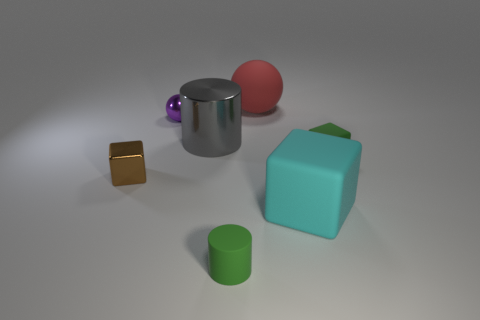What number of green rubber blocks are in front of the small green rubber thing that is behind the green object on the left side of the red matte thing?
Your answer should be compact. 0. There is a green object that is to the right of the cyan rubber block; how big is it?
Your answer should be compact. Small. What number of green rubber blocks are the same size as the gray object?
Your answer should be compact. 0. Is the size of the green rubber block the same as the cylinder behind the big cyan cube?
Your answer should be compact. No. How many things are shiny things or red balls?
Give a very brief answer. 4. How many metal things have the same color as the tiny shiny sphere?
Provide a succinct answer. 0. What is the shape of the purple object that is the same size as the metal cube?
Offer a very short reply. Sphere. Is there another object that has the same shape as the gray thing?
Ensure brevity in your answer.  Yes. What number of large objects are the same material as the small cylinder?
Your answer should be very brief. 2. Do the tiny block to the right of the big ball and the cyan object have the same material?
Ensure brevity in your answer.  Yes. 